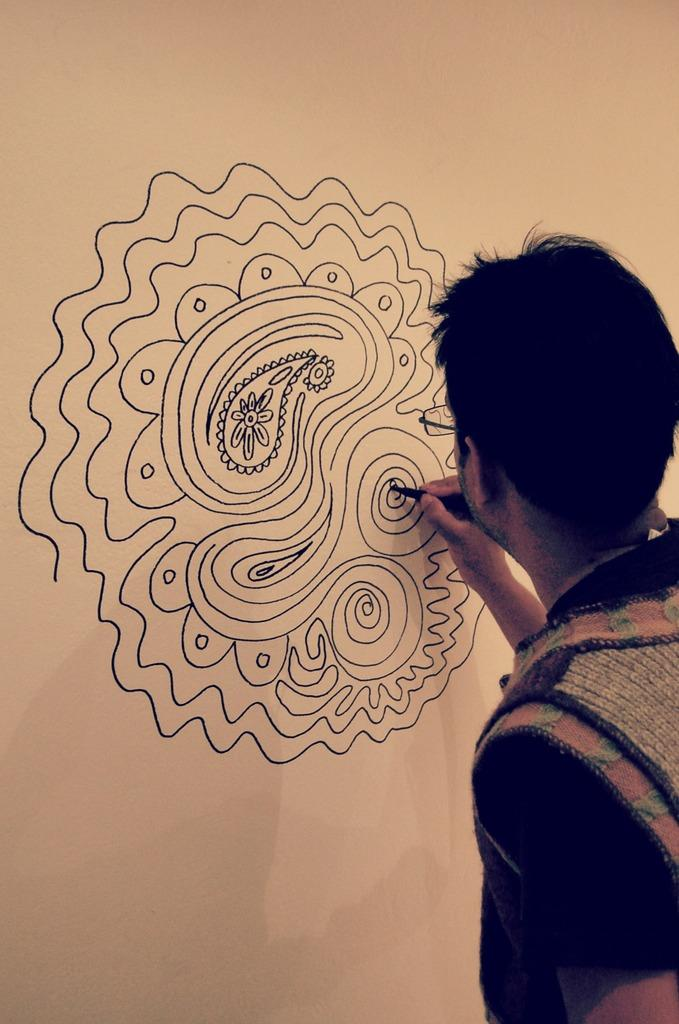What is the person in the image doing? The person in the image is drawing on a wall. What can be observed about the person's appearance? The person is wearing spectacles. What type of work is the person recording in the image? There is no indication in the image that the person is recording any work or activity. 